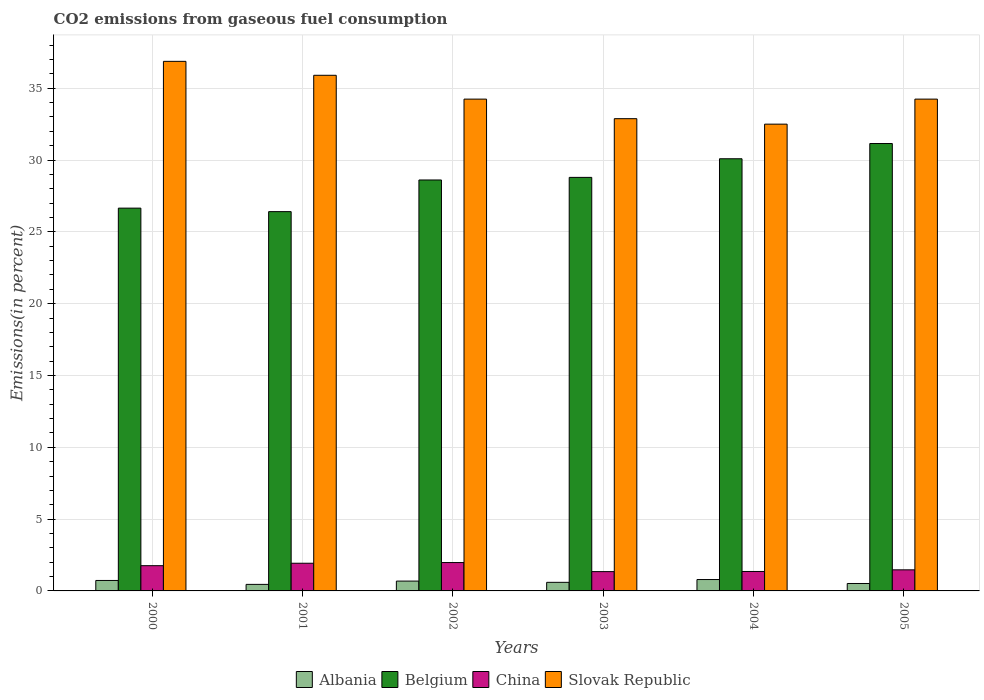Are the number of bars per tick equal to the number of legend labels?
Offer a terse response. Yes. Are the number of bars on each tick of the X-axis equal?
Your answer should be compact. Yes. How many bars are there on the 5th tick from the left?
Your answer should be very brief. 4. How many bars are there on the 3rd tick from the right?
Give a very brief answer. 4. What is the label of the 6th group of bars from the left?
Ensure brevity in your answer.  2005. What is the total CO2 emitted in Slovak Republic in 2002?
Give a very brief answer. 34.24. Across all years, what is the maximum total CO2 emitted in Slovak Republic?
Your answer should be compact. 36.87. Across all years, what is the minimum total CO2 emitted in Belgium?
Your answer should be compact. 26.41. In which year was the total CO2 emitted in Belgium maximum?
Keep it short and to the point. 2005. In which year was the total CO2 emitted in Slovak Republic minimum?
Your answer should be very brief. 2004. What is the total total CO2 emitted in Slovak Republic in the graph?
Make the answer very short. 206.62. What is the difference between the total CO2 emitted in Slovak Republic in 2001 and that in 2005?
Make the answer very short. 1.66. What is the difference between the total CO2 emitted in Belgium in 2005 and the total CO2 emitted in China in 2001?
Your response must be concise. 29.22. What is the average total CO2 emitted in Slovak Republic per year?
Your answer should be very brief. 34.44. In the year 2002, what is the difference between the total CO2 emitted in Slovak Republic and total CO2 emitted in Albania?
Keep it short and to the point. 33.56. In how many years, is the total CO2 emitted in China greater than 34 %?
Your answer should be very brief. 0. What is the ratio of the total CO2 emitted in Albania in 2001 to that in 2004?
Give a very brief answer. 0.57. Is the total CO2 emitted in Slovak Republic in 2000 less than that in 2003?
Give a very brief answer. No. Is the difference between the total CO2 emitted in Slovak Republic in 2002 and 2003 greater than the difference between the total CO2 emitted in Albania in 2002 and 2003?
Provide a succinct answer. Yes. What is the difference between the highest and the second highest total CO2 emitted in Slovak Republic?
Ensure brevity in your answer.  0.97. What is the difference between the highest and the lowest total CO2 emitted in China?
Ensure brevity in your answer.  0.63. Is the sum of the total CO2 emitted in Albania in 2000 and 2003 greater than the maximum total CO2 emitted in Belgium across all years?
Offer a very short reply. No. Is it the case that in every year, the sum of the total CO2 emitted in Belgium and total CO2 emitted in Slovak Republic is greater than the sum of total CO2 emitted in China and total CO2 emitted in Albania?
Offer a very short reply. Yes. What does the 3rd bar from the left in 2002 represents?
Ensure brevity in your answer.  China. How many bars are there?
Your answer should be compact. 24. Are all the bars in the graph horizontal?
Your answer should be compact. No. What is the difference between two consecutive major ticks on the Y-axis?
Provide a short and direct response. 5. Does the graph contain any zero values?
Provide a short and direct response. No. Where does the legend appear in the graph?
Ensure brevity in your answer.  Bottom center. What is the title of the graph?
Provide a short and direct response. CO2 emissions from gaseous fuel consumption. Does "Panama" appear as one of the legend labels in the graph?
Give a very brief answer. No. What is the label or title of the Y-axis?
Offer a terse response. Emissions(in percent). What is the Emissions(in percent) of Albania in 2000?
Your answer should be compact. 0.73. What is the Emissions(in percent) of Belgium in 2000?
Your response must be concise. 26.65. What is the Emissions(in percent) in China in 2000?
Give a very brief answer. 1.76. What is the Emissions(in percent) of Slovak Republic in 2000?
Offer a terse response. 36.87. What is the Emissions(in percent) of Albania in 2001?
Your answer should be compact. 0.46. What is the Emissions(in percent) in Belgium in 2001?
Give a very brief answer. 26.41. What is the Emissions(in percent) of China in 2001?
Make the answer very short. 1.93. What is the Emissions(in percent) in Slovak Republic in 2001?
Ensure brevity in your answer.  35.9. What is the Emissions(in percent) of Albania in 2002?
Make the answer very short. 0.68. What is the Emissions(in percent) in Belgium in 2002?
Offer a very short reply. 28.61. What is the Emissions(in percent) in China in 2002?
Offer a terse response. 1.98. What is the Emissions(in percent) in Slovak Republic in 2002?
Ensure brevity in your answer.  34.24. What is the Emissions(in percent) of Albania in 2003?
Make the answer very short. 0.6. What is the Emissions(in percent) of Belgium in 2003?
Your answer should be very brief. 28.79. What is the Emissions(in percent) of China in 2003?
Offer a terse response. 1.34. What is the Emissions(in percent) of Slovak Republic in 2003?
Offer a terse response. 32.88. What is the Emissions(in percent) in Albania in 2004?
Your answer should be compact. 0.79. What is the Emissions(in percent) in Belgium in 2004?
Provide a succinct answer. 30.09. What is the Emissions(in percent) of China in 2004?
Make the answer very short. 1.35. What is the Emissions(in percent) of Slovak Republic in 2004?
Offer a very short reply. 32.5. What is the Emissions(in percent) in Albania in 2005?
Make the answer very short. 0.52. What is the Emissions(in percent) of Belgium in 2005?
Provide a succinct answer. 31.15. What is the Emissions(in percent) in China in 2005?
Your answer should be compact. 1.47. What is the Emissions(in percent) in Slovak Republic in 2005?
Provide a short and direct response. 34.24. Across all years, what is the maximum Emissions(in percent) in Albania?
Offer a terse response. 0.79. Across all years, what is the maximum Emissions(in percent) of Belgium?
Ensure brevity in your answer.  31.15. Across all years, what is the maximum Emissions(in percent) in China?
Give a very brief answer. 1.98. Across all years, what is the maximum Emissions(in percent) in Slovak Republic?
Offer a very short reply. 36.87. Across all years, what is the minimum Emissions(in percent) in Albania?
Your answer should be very brief. 0.46. Across all years, what is the minimum Emissions(in percent) in Belgium?
Offer a very short reply. 26.41. Across all years, what is the minimum Emissions(in percent) in China?
Keep it short and to the point. 1.34. Across all years, what is the minimum Emissions(in percent) of Slovak Republic?
Your answer should be very brief. 32.5. What is the total Emissions(in percent) of Albania in the graph?
Your answer should be very brief. 3.77. What is the total Emissions(in percent) in Belgium in the graph?
Give a very brief answer. 171.69. What is the total Emissions(in percent) in China in the graph?
Your answer should be very brief. 9.83. What is the total Emissions(in percent) of Slovak Republic in the graph?
Your answer should be compact. 206.62. What is the difference between the Emissions(in percent) of Albania in 2000 and that in 2001?
Give a very brief answer. 0.27. What is the difference between the Emissions(in percent) in Belgium in 2000 and that in 2001?
Give a very brief answer. 0.24. What is the difference between the Emissions(in percent) of China in 2000 and that in 2001?
Your response must be concise. -0.17. What is the difference between the Emissions(in percent) in Slovak Republic in 2000 and that in 2001?
Keep it short and to the point. 0.97. What is the difference between the Emissions(in percent) in Albania in 2000 and that in 2002?
Provide a short and direct response. 0.04. What is the difference between the Emissions(in percent) of Belgium in 2000 and that in 2002?
Offer a terse response. -1.96. What is the difference between the Emissions(in percent) of China in 2000 and that in 2002?
Offer a terse response. -0.22. What is the difference between the Emissions(in percent) of Slovak Republic in 2000 and that in 2002?
Your answer should be compact. 2.63. What is the difference between the Emissions(in percent) in Albania in 2000 and that in 2003?
Give a very brief answer. 0.13. What is the difference between the Emissions(in percent) in Belgium in 2000 and that in 2003?
Your response must be concise. -2.14. What is the difference between the Emissions(in percent) of China in 2000 and that in 2003?
Keep it short and to the point. 0.41. What is the difference between the Emissions(in percent) in Slovak Republic in 2000 and that in 2003?
Your answer should be compact. 3.99. What is the difference between the Emissions(in percent) of Albania in 2000 and that in 2004?
Keep it short and to the point. -0.06. What is the difference between the Emissions(in percent) of Belgium in 2000 and that in 2004?
Offer a very short reply. -3.44. What is the difference between the Emissions(in percent) of China in 2000 and that in 2004?
Provide a succinct answer. 0.4. What is the difference between the Emissions(in percent) in Slovak Republic in 2000 and that in 2004?
Your answer should be very brief. 4.37. What is the difference between the Emissions(in percent) in Albania in 2000 and that in 2005?
Provide a short and direct response. 0.21. What is the difference between the Emissions(in percent) in Belgium in 2000 and that in 2005?
Offer a very short reply. -4.5. What is the difference between the Emissions(in percent) in China in 2000 and that in 2005?
Offer a terse response. 0.29. What is the difference between the Emissions(in percent) in Slovak Republic in 2000 and that in 2005?
Provide a short and direct response. 2.63. What is the difference between the Emissions(in percent) of Albania in 2001 and that in 2002?
Make the answer very short. -0.23. What is the difference between the Emissions(in percent) in Belgium in 2001 and that in 2002?
Ensure brevity in your answer.  -2.2. What is the difference between the Emissions(in percent) in China in 2001 and that in 2002?
Ensure brevity in your answer.  -0.05. What is the difference between the Emissions(in percent) of Slovak Republic in 2001 and that in 2002?
Ensure brevity in your answer.  1.66. What is the difference between the Emissions(in percent) of Albania in 2001 and that in 2003?
Provide a short and direct response. -0.14. What is the difference between the Emissions(in percent) in Belgium in 2001 and that in 2003?
Offer a very short reply. -2.38. What is the difference between the Emissions(in percent) in China in 2001 and that in 2003?
Keep it short and to the point. 0.58. What is the difference between the Emissions(in percent) in Slovak Republic in 2001 and that in 2003?
Provide a short and direct response. 3.02. What is the difference between the Emissions(in percent) of Albania in 2001 and that in 2004?
Your response must be concise. -0.34. What is the difference between the Emissions(in percent) of Belgium in 2001 and that in 2004?
Offer a terse response. -3.68. What is the difference between the Emissions(in percent) in China in 2001 and that in 2004?
Offer a terse response. 0.57. What is the difference between the Emissions(in percent) in Slovak Republic in 2001 and that in 2004?
Your response must be concise. 3.4. What is the difference between the Emissions(in percent) in Albania in 2001 and that in 2005?
Offer a very short reply. -0.06. What is the difference between the Emissions(in percent) of Belgium in 2001 and that in 2005?
Your response must be concise. -4.74. What is the difference between the Emissions(in percent) in China in 2001 and that in 2005?
Keep it short and to the point. 0.46. What is the difference between the Emissions(in percent) in Slovak Republic in 2001 and that in 2005?
Provide a succinct answer. 1.66. What is the difference between the Emissions(in percent) of Albania in 2002 and that in 2003?
Your response must be concise. 0.09. What is the difference between the Emissions(in percent) of Belgium in 2002 and that in 2003?
Provide a succinct answer. -0.18. What is the difference between the Emissions(in percent) in China in 2002 and that in 2003?
Offer a terse response. 0.63. What is the difference between the Emissions(in percent) of Slovak Republic in 2002 and that in 2003?
Your answer should be very brief. 1.36. What is the difference between the Emissions(in percent) in Albania in 2002 and that in 2004?
Make the answer very short. -0.11. What is the difference between the Emissions(in percent) of Belgium in 2002 and that in 2004?
Ensure brevity in your answer.  -1.48. What is the difference between the Emissions(in percent) in China in 2002 and that in 2004?
Make the answer very short. 0.62. What is the difference between the Emissions(in percent) in Slovak Republic in 2002 and that in 2004?
Your answer should be very brief. 1.74. What is the difference between the Emissions(in percent) of Albania in 2002 and that in 2005?
Your answer should be very brief. 0.17. What is the difference between the Emissions(in percent) of Belgium in 2002 and that in 2005?
Your response must be concise. -2.54. What is the difference between the Emissions(in percent) of China in 2002 and that in 2005?
Provide a succinct answer. 0.51. What is the difference between the Emissions(in percent) of Slovak Republic in 2002 and that in 2005?
Keep it short and to the point. -0. What is the difference between the Emissions(in percent) of Albania in 2003 and that in 2004?
Your answer should be compact. -0.19. What is the difference between the Emissions(in percent) in Belgium in 2003 and that in 2004?
Provide a succinct answer. -1.3. What is the difference between the Emissions(in percent) of China in 2003 and that in 2004?
Offer a very short reply. -0.01. What is the difference between the Emissions(in percent) in Slovak Republic in 2003 and that in 2004?
Offer a very short reply. 0.38. What is the difference between the Emissions(in percent) of Albania in 2003 and that in 2005?
Offer a terse response. 0.08. What is the difference between the Emissions(in percent) of Belgium in 2003 and that in 2005?
Your response must be concise. -2.36. What is the difference between the Emissions(in percent) of China in 2003 and that in 2005?
Your answer should be compact. -0.12. What is the difference between the Emissions(in percent) of Slovak Republic in 2003 and that in 2005?
Provide a succinct answer. -1.36. What is the difference between the Emissions(in percent) of Albania in 2004 and that in 2005?
Your response must be concise. 0.28. What is the difference between the Emissions(in percent) of Belgium in 2004 and that in 2005?
Make the answer very short. -1.06. What is the difference between the Emissions(in percent) of China in 2004 and that in 2005?
Give a very brief answer. -0.11. What is the difference between the Emissions(in percent) in Slovak Republic in 2004 and that in 2005?
Offer a terse response. -1.74. What is the difference between the Emissions(in percent) in Albania in 2000 and the Emissions(in percent) in Belgium in 2001?
Provide a short and direct response. -25.68. What is the difference between the Emissions(in percent) of Albania in 2000 and the Emissions(in percent) of China in 2001?
Your answer should be very brief. -1.2. What is the difference between the Emissions(in percent) of Albania in 2000 and the Emissions(in percent) of Slovak Republic in 2001?
Provide a short and direct response. -35.17. What is the difference between the Emissions(in percent) in Belgium in 2000 and the Emissions(in percent) in China in 2001?
Provide a short and direct response. 24.72. What is the difference between the Emissions(in percent) of Belgium in 2000 and the Emissions(in percent) of Slovak Republic in 2001?
Offer a terse response. -9.25. What is the difference between the Emissions(in percent) of China in 2000 and the Emissions(in percent) of Slovak Republic in 2001?
Offer a terse response. -34.14. What is the difference between the Emissions(in percent) of Albania in 2000 and the Emissions(in percent) of Belgium in 2002?
Your response must be concise. -27.88. What is the difference between the Emissions(in percent) of Albania in 2000 and the Emissions(in percent) of China in 2002?
Provide a short and direct response. -1.25. What is the difference between the Emissions(in percent) in Albania in 2000 and the Emissions(in percent) in Slovak Republic in 2002?
Your response must be concise. -33.51. What is the difference between the Emissions(in percent) of Belgium in 2000 and the Emissions(in percent) of China in 2002?
Offer a terse response. 24.67. What is the difference between the Emissions(in percent) in Belgium in 2000 and the Emissions(in percent) in Slovak Republic in 2002?
Your answer should be compact. -7.59. What is the difference between the Emissions(in percent) in China in 2000 and the Emissions(in percent) in Slovak Republic in 2002?
Offer a very short reply. -32.48. What is the difference between the Emissions(in percent) in Albania in 2000 and the Emissions(in percent) in Belgium in 2003?
Offer a terse response. -28.06. What is the difference between the Emissions(in percent) of Albania in 2000 and the Emissions(in percent) of China in 2003?
Keep it short and to the point. -0.62. What is the difference between the Emissions(in percent) of Albania in 2000 and the Emissions(in percent) of Slovak Republic in 2003?
Keep it short and to the point. -32.15. What is the difference between the Emissions(in percent) of Belgium in 2000 and the Emissions(in percent) of China in 2003?
Ensure brevity in your answer.  25.31. What is the difference between the Emissions(in percent) in Belgium in 2000 and the Emissions(in percent) in Slovak Republic in 2003?
Your answer should be compact. -6.23. What is the difference between the Emissions(in percent) of China in 2000 and the Emissions(in percent) of Slovak Republic in 2003?
Provide a short and direct response. -31.12. What is the difference between the Emissions(in percent) in Albania in 2000 and the Emissions(in percent) in Belgium in 2004?
Make the answer very short. -29.36. What is the difference between the Emissions(in percent) of Albania in 2000 and the Emissions(in percent) of China in 2004?
Give a very brief answer. -0.63. What is the difference between the Emissions(in percent) of Albania in 2000 and the Emissions(in percent) of Slovak Republic in 2004?
Provide a short and direct response. -31.77. What is the difference between the Emissions(in percent) of Belgium in 2000 and the Emissions(in percent) of China in 2004?
Offer a very short reply. 25.3. What is the difference between the Emissions(in percent) of Belgium in 2000 and the Emissions(in percent) of Slovak Republic in 2004?
Provide a succinct answer. -5.85. What is the difference between the Emissions(in percent) in China in 2000 and the Emissions(in percent) in Slovak Republic in 2004?
Give a very brief answer. -30.74. What is the difference between the Emissions(in percent) in Albania in 2000 and the Emissions(in percent) in Belgium in 2005?
Offer a very short reply. -30.42. What is the difference between the Emissions(in percent) of Albania in 2000 and the Emissions(in percent) of China in 2005?
Offer a terse response. -0.74. What is the difference between the Emissions(in percent) in Albania in 2000 and the Emissions(in percent) in Slovak Republic in 2005?
Make the answer very short. -33.51. What is the difference between the Emissions(in percent) of Belgium in 2000 and the Emissions(in percent) of China in 2005?
Offer a very short reply. 25.18. What is the difference between the Emissions(in percent) in Belgium in 2000 and the Emissions(in percent) in Slovak Republic in 2005?
Provide a succinct answer. -7.59. What is the difference between the Emissions(in percent) of China in 2000 and the Emissions(in percent) of Slovak Republic in 2005?
Give a very brief answer. -32.48. What is the difference between the Emissions(in percent) of Albania in 2001 and the Emissions(in percent) of Belgium in 2002?
Keep it short and to the point. -28.16. What is the difference between the Emissions(in percent) in Albania in 2001 and the Emissions(in percent) in China in 2002?
Give a very brief answer. -1.52. What is the difference between the Emissions(in percent) in Albania in 2001 and the Emissions(in percent) in Slovak Republic in 2002?
Give a very brief answer. -33.78. What is the difference between the Emissions(in percent) of Belgium in 2001 and the Emissions(in percent) of China in 2002?
Offer a terse response. 24.43. What is the difference between the Emissions(in percent) in Belgium in 2001 and the Emissions(in percent) in Slovak Republic in 2002?
Make the answer very short. -7.83. What is the difference between the Emissions(in percent) of China in 2001 and the Emissions(in percent) of Slovak Republic in 2002?
Make the answer very short. -32.31. What is the difference between the Emissions(in percent) in Albania in 2001 and the Emissions(in percent) in Belgium in 2003?
Offer a terse response. -28.34. What is the difference between the Emissions(in percent) in Albania in 2001 and the Emissions(in percent) in China in 2003?
Make the answer very short. -0.89. What is the difference between the Emissions(in percent) in Albania in 2001 and the Emissions(in percent) in Slovak Republic in 2003?
Provide a succinct answer. -32.42. What is the difference between the Emissions(in percent) in Belgium in 2001 and the Emissions(in percent) in China in 2003?
Offer a very short reply. 25.06. What is the difference between the Emissions(in percent) in Belgium in 2001 and the Emissions(in percent) in Slovak Republic in 2003?
Offer a very short reply. -6.47. What is the difference between the Emissions(in percent) of China in 2001 and the Emissions(in percent) of Slovak Republic in 2003?
Your response must be concise. -30.95. What is the difference between the Emissions(in percent) of Albania in 2001 and the Emissions(in percent) of Belgium in 2004?
Offer a terse response. -29.63. What is the difference between the Emissions(in percent) of Albania in 2001 and the Emissions(in percent) of China in 2004?
Your answer should be very brief. -0.9. What is the difference between the Emissions(in percent) of Albania in 2001 and the Emissions(in percent) of Slovak Republic in 2004?
Make the answer very short. -32.04. What is the difference between the Emissions(in percent) of Belgium in 2001 and the Emissions(in percent) of China in 2004?
Give a very brief answer. 25.05. What is the difference between the Emissions(in percent) of Belgium in 2001 and the Emissions(in percent) of Slovak Republic in 2004?
Your answer should be very brief. -6.09. What is the difference between the Emissions(in percent) in China in 2001 and the Emissions(in percent) in Slovak Republic in 2004?
Make the answer very short. -30.57. What is the difference between the Emissions(in percent) of Albania in 2001 and the Emissions(in percent) of Belgium in 2005?
Offer a terse response. -30.69. What is the difference between the Emissions(in percent) of Albania in 2001 and the Emissions(in percent) of China in 2005?
Your response must be concise. -1.01. What is the difference between the Emissions(in percent) in Albania in 2001 and the Emissions(in percent) in Slovak Republic in 2005?
Your answer should be very brief. -33.79. What is the difference between the Emissions(in percent) of Belgium in 2001 and the Emissions(in percent) of China in 2005?
Provide a succinct answer. 24.94. What is the difference between the Emissions(in percent) in Belgium in 2001 and the Emissions(in percent) in Slovak Republic in 2005?
Provide a succinct answer. -7.83. What is the difference between the Emissions(in percent) in China in 2001 and the Emissions(in percent) in Slovak Republic in 2005?
Your response must be concise. -32.31. What is the difference between the Emissions(in percent) in Albania in 2002 and the Emissions(in percent) in Belgium in 2003?
Your answer should be compact. -28.11. What is the difference between the Emissions(in percent) of Albania in 2002 and the Emissions(in percent) of China in 2003?
Provide a short and direct response. -0.66. What is the difference between the Emissions(in percent) in Albania in 2002 and the Emissions(in percent) in Slovak Republic in 2003?
Offer a terse response. -32.19. What is the difference between the Emissions(in percent) in Belgium in 2002 and the Emissions(in percent) in China in 2003?
Provide a succinct answer. 27.27. What is the difference between the Emissions(in percent) in Belgium in 2002 and the Emissions(in percent) in Slovak Republic in 2003?
Give a very brief answer. -4.27. What is the difference between the Emissions(in percent) of China in 2002 and the Emissions(in percent) of Slovak Republic in 2003?
Offer a terse response. -30.9. What is the difference between the Emissions(in percent) of Albania in 2002 and the Emissions(in percent) of Belgium in 2004?
Keep it short and to the point. -29.4. What is the difference between the Emissions(in percent) of Albania in 2002 and the Emissions(in percent) of China in 2004?
Your answer should be very brief. -0.67. What is the difference between the Emissions(in percent) of Albania in 2002 and the Emissions(in percent) of Slovak Republic in 2004?
Make the answer very short. -31.81. What is the difference between the Emissions(in percent) of Belgium in 2002 and the Emissions(in percent) of China in 2004?
Offer a very short reply. 27.26. What is the difference between the Emissions(in percent) of Belgium in 2002 and the Emissions(in percent) of Slovak Republic in 2004?
Offer a very short reply. -3.89. What is the difference between the Emissions(in percent) in China in 2002 and the Emissions(in percent) in Slovak Republic in 2004?
Provide a short and direct response. -30.52. What is the difference between the Emissions(in percent) in Albania in 2002 and the Emissions(in percent) in Belgium in 2005?
Keep it short and to the point. -30.46. What is the difference between the Emissions(in percent) of Albania in 2002 and the Emissions(in percent) of China in 2005?
Keep it short and to the point. -0.78. What is the difference between the Emissions(in percent) of Albania in 2002 and the Emissions(in percent) of Slovak Republic in 2005?
Provide a succinct answer. -33.56. What is the difference between the Emissions(in percent) of Belgium in 2002 and the Emissions(in percent) of China in 2005?
Your response must be concise. 27.14. What is the difference between the Emissions(in percent) of Belgium in 2002 and the Emissions(in percent) of Slovak Republic in 2005?
Make the answer very short. -5.63. What is the difference between the Emissions(in percent) in China in 2002 and the Emissions(in percent) in Slovak Republic in 2005?
Your answer should be compact. -32.26. What is the difference between the Emissions(in percent) in Albania in 2003 and the Emissions(in percent) in Belgium in 2004?
Provide a short and direct response. -29.49. What is the difference between the Emissions(in percent) in Albania in 2003 and the Emissions(in percent) in China in 2004?
Provide a short and direct response. -0.76. What is the difference between the Emissions(in percent) of Albania in 2003 and the Emissions(in percent) of Slovak Republic in 2004?
Give a very brief answer. -31.9. What is the difference between the Emissions(in percent) of Belgium in 2003 and the Emissions(in percent) of China in 2004?
Your answer should be compact. 27.44. What is the difference between the Emissions(in percent) in Belgium in 2003 and the Emissions(in percent) in Slovak Republic in 2004?
Offer a terse response. -3.71. What is the difference between the Emissions(in percent) of China in 2003 and the Emissions(in percent) of Slovak Republic in 2004?
Your answer should be very brief. -31.15. What is the difference between the Emissions(in percent) of Albania in 2003 and the Emissions(in percent) of Belgium in 2005?
Make the answer very short. -30.55. What is the difference between the Emissions(in percent) in Albania in 2003 and the Emissions(in percent) in China in 2005?
Your answer should be very brief. -0.87. What is the difference between the Emissions(in percent) in Albania in 2003 and the Emissions(in percent) in Slovak Republic in 2005?
Offer a very short reply. -33.64. What is the difference between the Emissions(in percent) of Belgium in 2003 and the Emissions(in percent) of China in 2005?
Give a very brief answer. 27.32. What is the difference between the Emissions(in percent) of Belgium in 2003 and the Emissions(in percent) of Slovak Republic in 2005?
Ensure brevity in your answer.  -5.45. What is the difference between the Emissions(in percent) in China in 2003 and the Emissions(in percent) in Slovak Republic in 2005?
Offer a very short reply. -32.9. What is the difference between the Emissions(in percent) in Albania in 2004 and the Emissions(in percent) in Belgium in 2005?
Your response must be concise. -30.36. What is the difference between the Emissions(in percent) of Albania in 2004 and the Emissions(in percent) of China in 2005?
Offer a very short reply. -0.68. What is the difference between the Emissions(in percent) in Albania in 2004 and the Emissions(in percent) in Slovak Republic in 2005?
Offer a very short reply. -33.45. What is the difference between the Emissions(in percent) in Belgium in 2004 and the Emissions(in percent) in China in 2005?
Provide a succinct answer. 28.62. What is the difference between the Emissions(in percent) in Belgium in 2004 and the Emissions(in percent) in Slovak Republic in 2005?
Your response must be concise. -4.15. What is the difference between the Emissions(in percent) in China in 2004 and the Emissions(in percent) in Slovak Republic in 2005?
Offer a terse response. -32.89. What is the average Emissions(in percent) in Albania per year?
Your answer should be compact. 0.63. What is the average Emissions(in percent) in Belgium per year?
Your answer should be compact. 28.62. What is the average Emissions(in percent) in China per year?
Your answer should be very brief. 1.64. What is the average Emissions(in percent) in Slovak Republic per year?
Your answer should be compact. 34.44. In the year 2000, what is the difference between the Emissions(in percent) in Albania and Emissions(in percent) in Belgium?
Provide a short and direct response. -25.92. In the year 2000, what is the difference between the Emissions(in percent) in Albania and Emissions(in percent) in China?
Provide a short and direct response. -1.03. In the year 2000, what is the difference between the Emissions(in percent) in Albania and Emissions(in percent) in Slovak Republic?
Give a very brief answer. -36.14. In the year 2000, what is the difference between the Emissions(in percent) of Belgium and Emissions(in percent) of China?
Ensure brevity in your answer.  24.89. In the year 2000, what is the difference between the Emissions(in percent) in Belgium and Emissions(in percent) in Slovak Republic?
Offer a very short reply. -10.22. In the year 2000, what is the difference between the Emissions(in percent) of China and Emissions(in percent) of Slovak Republic?
Make the answer very short. -35.11. In the year 2001, what is the difference between the Emissions(in percent) in Albania and Emissions(in percent) in Belgium?
Your response must be concise. -25.95. In the year 2001, what is the difference between the Emissions(in percent) in Albania and Emissions(in percent) in China?
Offer a very short reply. -1.47. In the year 2001, what is the difference between the Emissions(in percent) in Albania and Emissions(in percent) in Slovak Republic?
Offer a terse response. -35.44. In the year 2001, what is the difference between the Emissions(in percent) of Belgium and Emissions(in percent) of China?
Provide a short and direct response. 24.48. In the year 2001, what is the difference between the Emissions(in percent) of Belgium and Emissions(in percent) of Slovak Republic?
Provide a succinct answer. -9.49. In the year 2001, what is the difference between the Emissions(in percent) in China and Emissions(in percent) in Slovak Republic?
Offer a terse response. -33.97. In the year 2002, what is the difference between the Emissions(in percent) in Albania and Emissions(in percent) in Belgium?
Your answer should be very brief. -27.93. In the year 2002, what is the difference between the Emissions(in percent) of Albania and Emissions(in percent) of China?
Offer a very short reply. -1.29. In the year 2002, what is the difference between the Emissions(in percent) in Albania and Emissions(in percent) in Slovak Republic?
Ensure brevity in your answer.  -33.56. In the year 2002, what is the difference between the Emissions(in percent) of Belgium and Emissions(in percent) of China?
Offer a terse response. 26.64. In the year 2002, what is the difference between the Emissions(in percent) in Belgium and Emissions(in percent) in Slovak Republic?
Your response must be concise. -5.63. In the year 2002, what is the difference between the Emissions(in percent) of China and Emissions(in percent) of Slovak Republic?
Your answer should be very brief. -32.26. In the year 2003, what is the difference between the Emissions(in percent) of Albania and Emissions(in percent) of Belgium?
Ensure brevity in your answer.  -28.19. In the year 2003, what is the difference between the Emissions(in percent) in Albania and Emissions(in percent) in China?
Keep it short and to the point. -0.75. In the year 2003, what is the difference between the Emissions(in percent) of Albania and Emissions(in percent) of Slovak Republic?
Make the answer very short. -32.28. In the year 2003, what is the difference between the Emissions(in percent) of Belgium and Emissions(in percent) of China?
Make the answer very short. 27.45. In the year 2003, what is the difference between the Emissions(in percent) of Belgium and Emissions(in percent) of Slovak Republic?
Keep it short and to the point. -4.09. In the year 2003, what is the difference between the Emissions(in percent) of China and Emissions(in percent) of Slovak Republic?
Provide a succinct answer. -31.53. In the year 2004, what is the difference between the Emissions(in percent) of Albania and Emissions(in percent) of Belgium?
Make the answer very short. -29.3. In the year 2004, what is the difference between the Emissions(in percent) in Albania and Emissions(in percent) in China?
Offer a very short reply. -0.56. In the year 2004, what is the difference between the Emissions(in percent) in Albania and Emissions(in percent) in Slovak Republic?
Provide a short and direct response. -31.71. In the year 2004, what is the difference between the Emissions(in percent) of Belgium and Emissions(in percent) of China?
Your answer should be very brief. 28.73. In the year 2004, what is the difference between the Emissions(in percent) of Belgium and Emissions(in percent) of Slovak Republic?
Your answer should be compact. -2.41. In the year 2004, what is the difference between the Emissions(in percent) of China and Emissions(in percent) of Slovak Republic?
Provide a succinct answer. -31.14. In the year 2005, what is the difference between the Emissions(in percent) in Albania and Emissions(in percent) in Belgium?
Your answer should be very brief. -30.63. In the year 2005, what is the difference between the Emissions(in percent) of Albania and Emissions(in percent) of China?
Your response must be concise. -0.95. In the year 2005, what is the difference between the Emissions(in percent) of Albania and Emissions(in percent) of Slovak Republic?
Keep it short and to the point. -33.72. In the year 2005, what is the difference between the Emissions(in percent) in Belgium and Emissions(in percent) in China?
Keep it short and to the point. 29.68. In the year 2005, what is the difference between the Emissions(in percent) of Belgium and Emissions(in percent) of Slovak Republic?
Offer a terse response. -3.09. In the year 2005, what is the difference between the Emissions(in percent) in China and Emissions(in percent) in Slovak Republic?
Provide a short and direct response. -32.77. What is the ratio of the Emissions(in percent) of Albania in 2000 to that in 2001?
Make the answer very short. 1.6. What is the ratio of the Emissions(in percent) in Belgium in 2000 to that in 2001?
Provide a succinct answer. 1.01. What is the ratio of the Emissions(in percent) in China in 2000 to that in 2001?
Provide a short and direct response. 0.91. What is the ratio of the Emissions(in percent) of Slovak Republic in 2000 to that in 2001?
Provide a succinct answer. 1.03. What is the ratio of the Emissions(in percent) of Albania in 2000 to that in 2002?
Provide a short and direct response. 1.06. What is the ratio of the Emissions(in percent) in Belgium in 2000 to that in 2002?
Your answer should be very brief. 0.93. What is the ratio of the Emissions(in percent) of China in 2000 to that in 2002?
Ensure brevity in your answer.  0.89. What is the ratio of the Emissions(in percent) in Slovak Republic in 2000 to that in 2002?
Provide a short and direct response. 1.08. What is the ratio of the Emissions(in percent) of Albania in 2000 to that in 2003?
Provide a short and direct response. 1.22. What is the ratio of the Emissions(in percent) of Belgium in 2000 to that in 2003?
Your answer should be very brief. 0.93. What is the ratio of the Emissions(in percent) in China in 2000 to that in 2003?
Keep it short and to the point. 1.31. What is the ratio of the Emissions(in percent) in Slovak Republic in 2000 to that in 2003?
Your response must be concise. 1.12. What is the ratio of the Emissions(in percent) in Albania in 2000 to that in 2004?
Keep it short and to the point. 0.92. What is the ratio of the Emissions(in percent) of Belgium in 2000 to that in 2004?
Provide a short and direct response. 0.89. What is the ratio of the Emissions(in percent) in China in 2000 to that in 2004?
Offer a very short reply. 1.3. What is the ratio of the Emissions(in percent) in Slovak Republic in 2000 to that in 2004?
Make the answer very short. 1.13. What is the ratio of the Emissions(in percent) of Albania in 2000 to that in 2005?
Provide a short and direct response. 1.41. What is the ratio of the Emissions(in percent) in Belgium in 2000 to that in 2005?
Keep it short and to the point. 0.86. What is the ratio of the Emissions(in percent) in China in 2000 to that in 2005?
Offer a terse response. 1.2. What is the ratio of the Emissions(in percent) in Slovak Republic in 2000 to that in 2005?
Provide a short and direct response. 1.08. What is the ratio of the Emissions(in percent) of Albania in 2001 to that in 2002?
Provide a succinct answer. 0.67. What is the ratio of the Emissions(in percent) of Belgium in 2001 to that in 2002?
Make the answer very short. 0.92. What is the ratio of the Emissions(in percent) of China in 2001 to that in 2002?
Make the answer very short. 0.98. What is the ratio of the Emissions(in percent) of Slovak Republic in 2001 to that in 2002?
Offer a very short reply. 1.05. What is the ratio of the Emissions(in percent) of Albania in 2001 to that in 2003?
Offer a terse response. 0.76. What is the ratio of the Emissions(in percent) of Belgium in 2001 to that in 2003?
Your response must be concise. 0.92. What is the ratio of the Emissions(in percent) of China in 2001 to that in 2003?
Provide a succinct answer. 1.43. What is the ratio of the Emissions(in percent) in Slovak Republic in 2001 to that in 2003?
Offer a terse response. 1.09. What is the ratio of the Emissions(in percent) in Albania in 2001 to that in 2004?
Offer a terse response. 0.57. What is the ratio of the Emissions(in percent) of Belgium in 2001 to that in 2004?
Offer a terse response. 0.88. What is the ratio of the Emissions(in percent) in China in 2001 to that in 2004?
Your response must be concise. 1.42. What is the ratio of the Emissions(in percent) of Slovak Republic in 2001 to that in 2004?
Give a very brief answer. 1.1. What is the ratio of the Emissions(in percent) of Albania in 2001 to that in 2005?
Make the answer very short. 0.88. What is the ratio of the Emissions(in percent) in Belgium in 2001 to that in 2005?
Keep it short and to the point. 0.85. What is the ratio of the Emissions(in percent) of China in 2001 to that in 2005?
Make the answer very short. 1.31. What is the ratio of the Emissions(in percent) of Slovak Republic in 2001 to that in 2005?
Keep it short and to the point. 1.05. What is the ratio of the Emissions(in percent) in Albania in 2002 to that in 2003?
Offer a terse response. 1.14. What is the ratio of the Emissions(in percent) of Belgium in 2002 to that in 2003?
Your answer should be very brief. 0.99. What is the ratio of the Emissions(in percent) in China in 2002 to that in 2003?
Offer a terse response. 1.47. What is the ratio of the Emissions(in percent) in Slovak Republic in 2002 to that in 2003?
Keep it short and to the point. 1.04. What is the ratio of the Emissions(in percent) in Albania in 2002 to that in 2004?
Make the answer very short. 0.86. What is the ratio of the Emissions(in percent) of Belgium in 2002 to that in 2004?
Make the answer very short. 0.95. What is the ratio of the Emissions(in percent) in China in 2002 to that in 2004?
Keep it short and to the point. 1.46. What is the ratio of the Emissions(in percent) of Slovak Republic in 2002 to that in 2004?
Your response must be concise. 1.05. What is the ratio of the Emissions(in percent) of Albania in 2002 to that in 2005?
Your answer should be very brief. 1.32. What is the ratio of the Emissions(in percent) in Belgium in 2002 to that in 2005?
Your answer should be compact. 0.92. What is the ratio of the Emissions(in percent) in China in 2002 to that in 2005?
Keep it short and to the point. 1.35. What is the ratio of the Emissions(in percent) of Slovak Republic in 2002 to that in 2005?
Ensure brevity in your answer.  1. What is the ratio of the Emissions(in percent) of Albania in 2003 to that in 2004?
Provide a succinct answer. 0.75. What is the ratio of the Emissions(in percent) of Belgium in 2003 to that in 2004?
Ensure brevity in your answer.  0.96. What is the ratio of the Emissions(in percent) in China in 2003 to that in 2004?
Keep it short and to the point. 0.99. What is the ratio of the Emissions(in percent) of Slovak Republic in 2003 to that in 2004?
Make the answer very short. 1.01. What is the ratio of the Emissions(in percent) of Albania in 2003 to that in 2005?
Make the answer very short. 1.16. What is the ratio of the Emissions(in percent) of Belgium in 2003 to that in 2005?
Offer a very short reply. 0.92. What is the ratio of the Emissions(in percent) of China in 2003 to that in 2005?
Provide a succinct answer. 0.91. What is the ratio of the Emissions(in percent) of Slovak Republic in 2003 to that in 2005?
Your answer should be very brief. 0.96. What is the ratio of the Emissions(in percent) in Albania in 2004 to that in 2005?
Ensure brevity in your answer.  1.53. What is the ratio of the Emissions(in percent) in Belgium in 2004 to that in 2005?
Give a very brief answer. 0.97. What is the ratio of the Emissions(in percent) in China in 2004 to that in 2005?
Provide a succinct answer. 0.92. What is the ratio of the Emissions(in percent) of Slovak Republic in 2004 to that in 2005?
Provide a short and direct response. 0.95. What is the difference between the highest and the second highest Emissions(in percent) in Albania?
Give a very brief answer. 0.06. What is the difference between the highest and the second highest Emissions(in percent) of Belgium?
Your answer should be very brief. 1.06. What is the difference between the highest and the second highest Emissions(in percent) in China?
Your answer should be compact. 0.05. What is the difference between the highest and the second highest Emissions(in percent) of Slovak Republic?
Make the answer very short. 0.97. What is the difference between the highest and the lowest Emissions(in percent) of Albania?
Keep it short and to the point. 0.34. What is the difference between the highest and the lowest Emissions(in percent) in Belgium?
Offer a terse response. 4.74. What is the difference between the highest and the lowest Emissions(in percent) of China?
Give a very brief answer. 0.63. What is the difference between the highest and the lowest Emissions(in percent) in Slovak Republic?
Your answer should be compact. 4.37. 